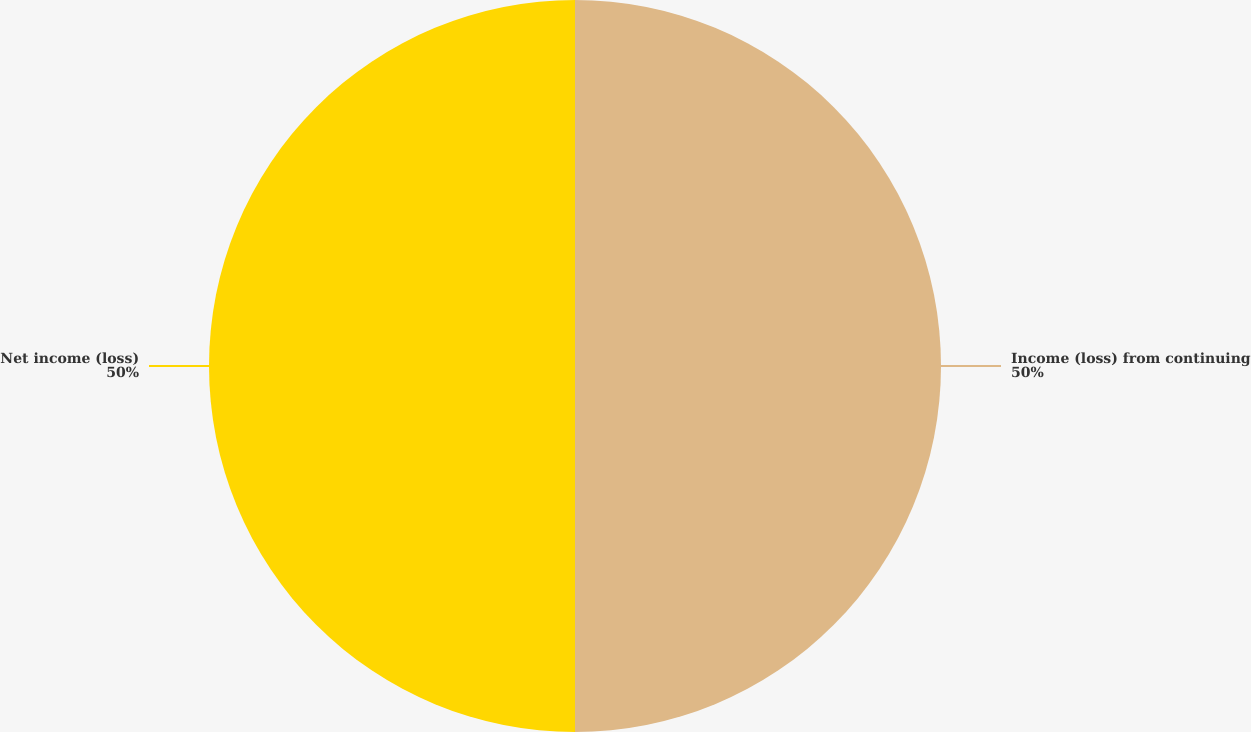<chart> <loc_0><loc_0><loc_500><loc_500><pie_chart><fcel>Income (loss) from continuing<fcel>Net income (loss)<nl><fcel>50.0%<fcel>50.0%<nl></chart> 